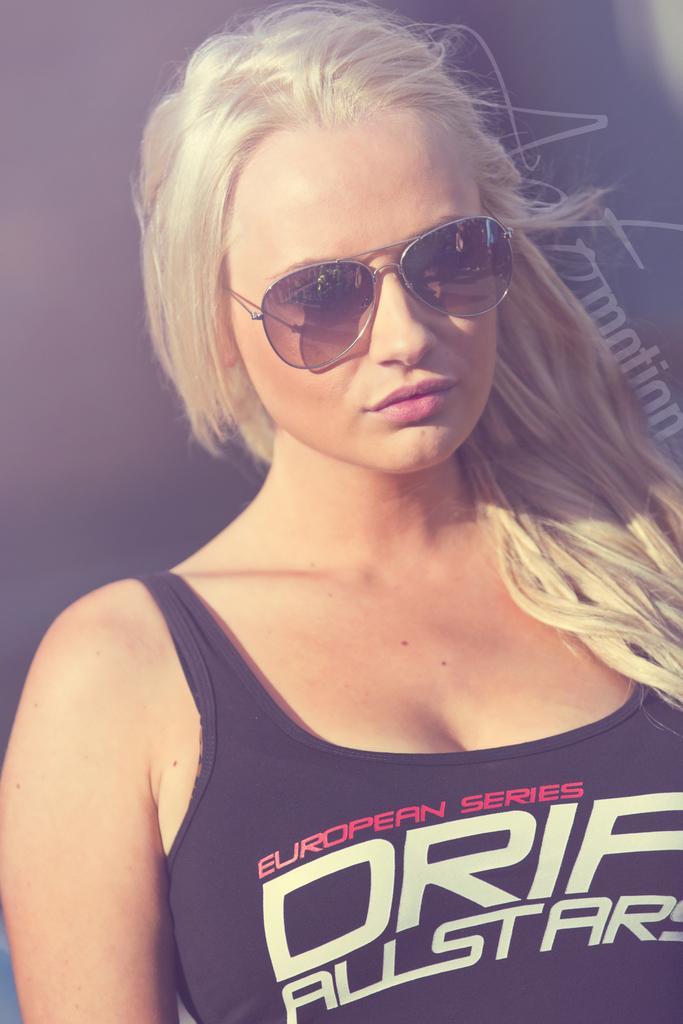Could you give a brief overview of what you see in this image? In this image there is a lady wearing sunglasses and black t-shirt. 